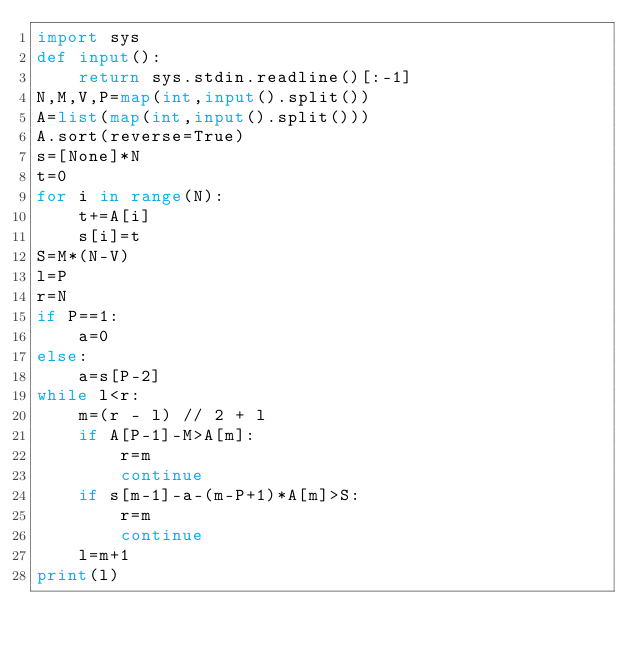<code> <loc_0><loc_0><loc_500><loc_500><_Python_>import sys
def input():
    return sys.stdin.readline()[:-1]
N,M,V,P=map(int,input().split())
A=list(map(int,input().split()))
A.sort(reverse=True)
s=[None]*N
t=0
for i in range(N):
    t+=A[i]
    s[i]=t
S=M*(N-V)
l=P
r=N
if P==1:
    a=0
else:
    a=s[P-2]
while l<r:
    m=(r - l) // 2 + l
    if A[P-1]-M>A[m]:
        r=m
        continue
    if s[m-1]-a-(m-P+1)*A[m]>S:
        r=m
        continue
    l=m+1
print(l)</code> 